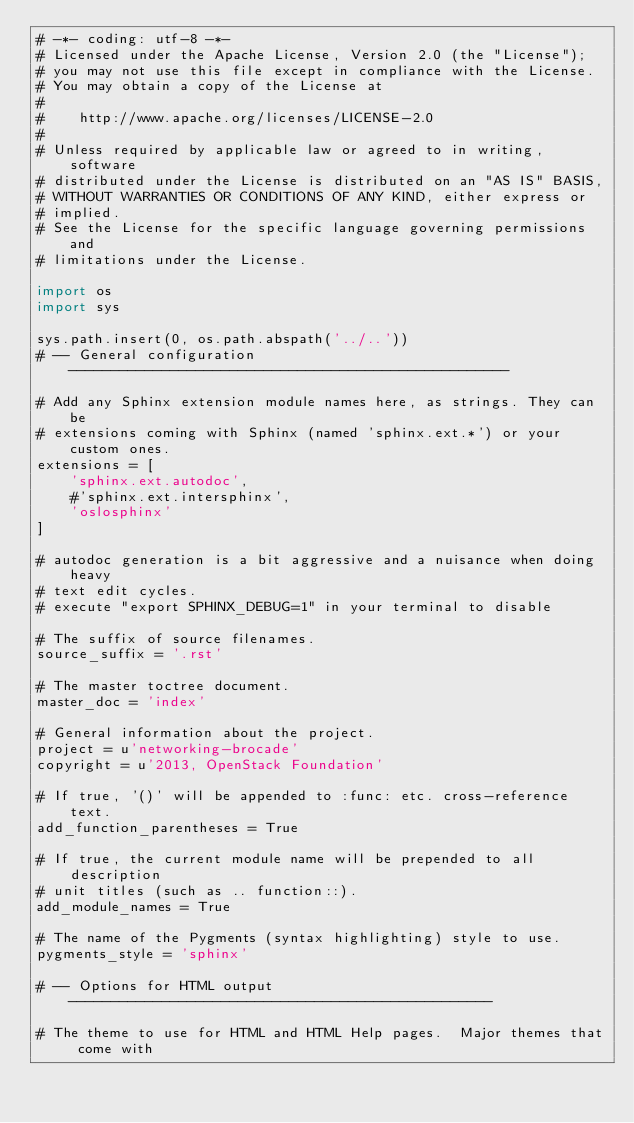<code> <loc_0><loc_0><loc_500><loc_500><_Python_># -*- coding: utf-8 -*-
# Licensed under the Apache License, Version 2.0 (the "License");
# you may not use this file except in compliance with the License.
# You may obtain a copy of the License at
#
#    http://www.apache.org/licenses/LICENSE-2.0
#
# Unless required by applicable law or agreed to in writing, software
# distributed under the License is distributed on an "AS IS" BASIS,
# WITHOUT WARRANTIES OR CONDITIONS OF ANY KIND, either express or
# implied.
# See the License for the specific language governing permissions and
# limitations under the License.

import os
import sys

sys.path.insert(0, os.path.abspath('../..'))
# -- General configuration ----------------------------------------------------

# Add any Sphinx extension module names here, as strings. They can be
# extensions coming with Sphinx (named 'sphinx.ext.*') or your custom ones.
extensions = [
    'sphinx.ext.autodoc',
    #'sphinx.ext.intersphinx',
    'oslosphinx'
]

# autodoc generation is a bit aggressive and a nuisance when doing heavy
# text edit cycles.
# execute "export SPHINX_DEBUG=1" in your terminal to disable

# The suffix of source filenames.
source_suffix = '.rst'

# The master toctree document.
master_doc = 'index'

# General information about the project.
project = u'networking-brocade'
copyright = u'2013, OpenStack Foundation'

# If true, '()' will be appended to :func: etc. cross-reference text.
add_function_parentheses = True

# If true, the current module name will be prepended to all description
# unit titles (such as .. function::).
add_module_names = True

# The name of the Pygments (syntax highlighting) style to use.
pygments_style = 'sphinx'

# -- Options for HTML output --------------------------------------------------

# The theme to use for HTML and HTML Help pages.  Major themes that come with</code> 